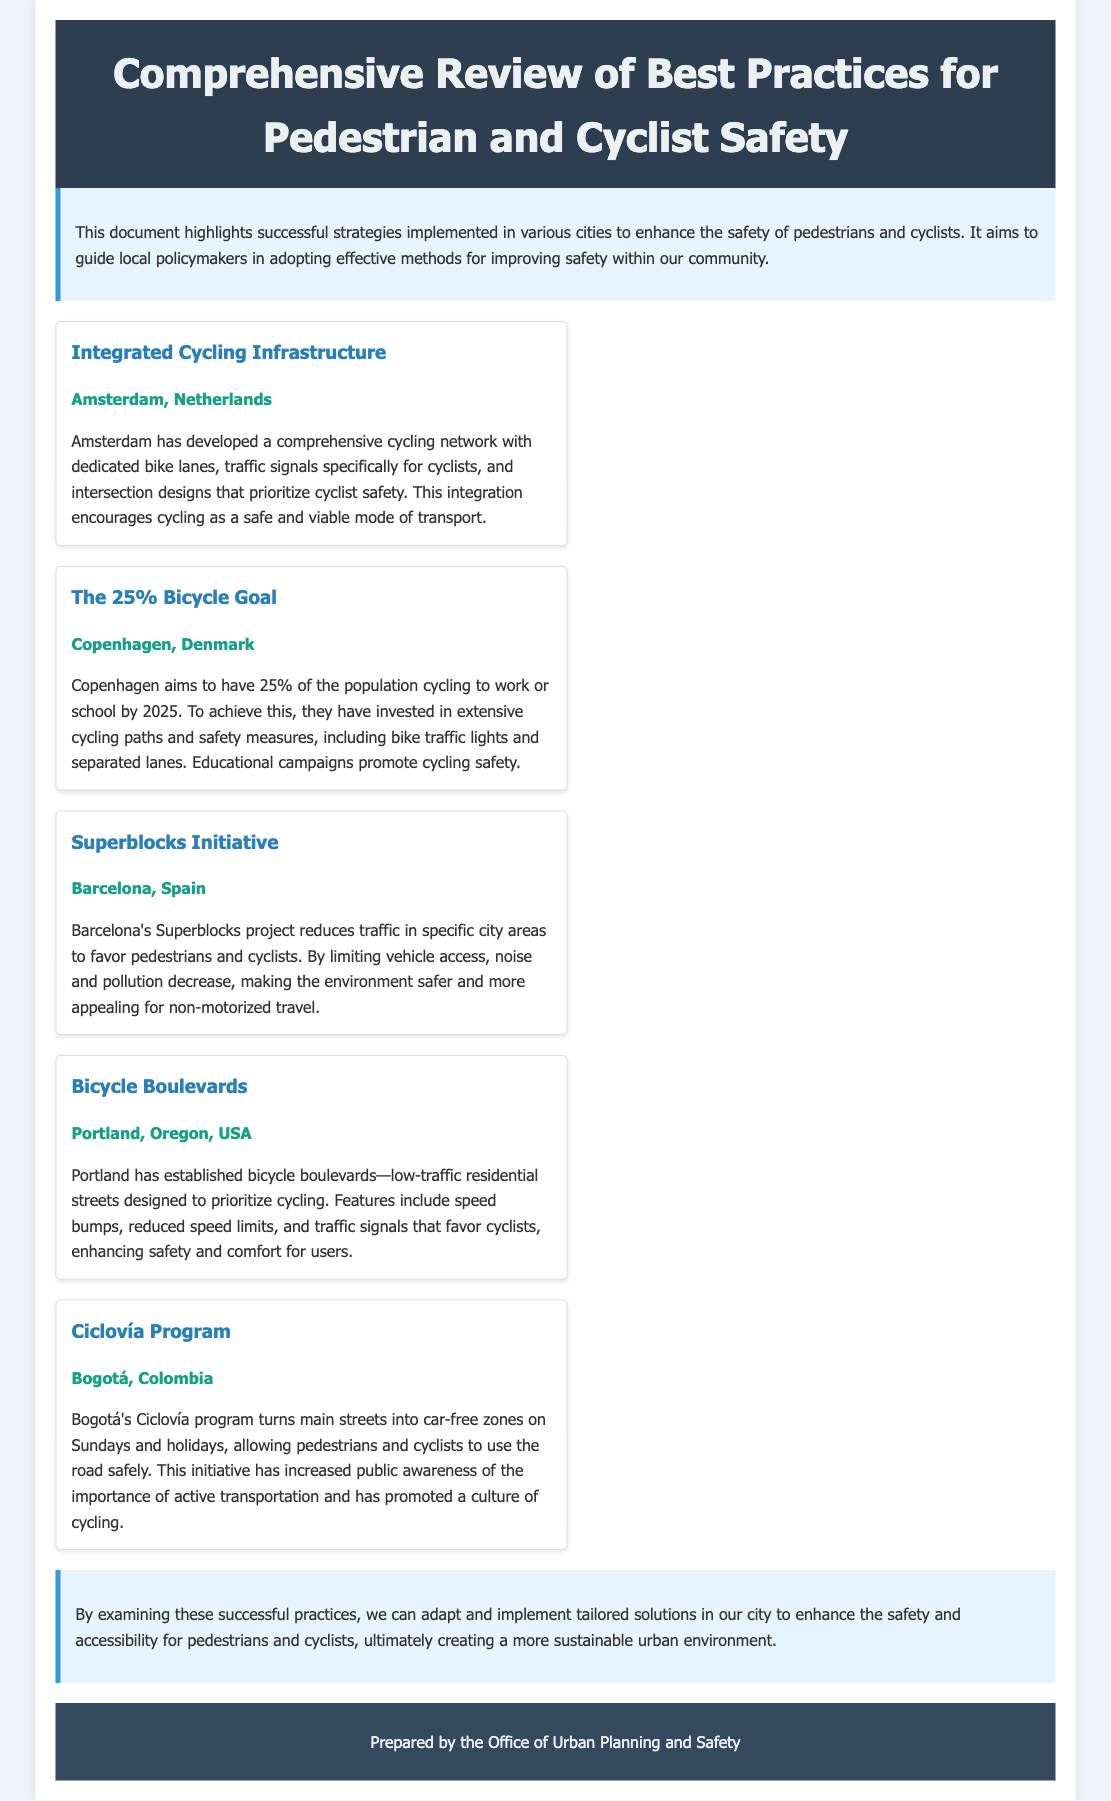What city is known for its Integrated Cycling Infrastructure? The document states that Amsterdam has developed a comprehensive cycling network with dedicated bike lanes, traffic signals specifically for cyclists, and intersection designs that prioritize cyclist safety.
Answer: Amsterdam What percentage of the population in Copenhagen aims to cycle by 2025? The text indicates that Copenhagen aims to have 25% of the population cycling to work or school by 2025.
Answer: 25% What initiative is aimed at reducing traffic and favoring pedestrians and cyclists in Barcelona? According to the document, Barcelona's Superblocks project reduces traffic in specific city areas to favor pedestrians and cyclists.
Answer: Superblocks Initiative What type of streets are Bicycle Boulevards designed for? The document describes that Portland has established bicycle boulevards—low-traffic residential streets designed to prioritize cycling.
Answer: Residential streets What does Bogotá's Ciclovía program do on Sundays and holidays? The text specifies that Bogotá's Ciclovía program turns main streets into car-free zones on Sundays and holidays, allowing pedestrians and cyclists to use the road safely.
Answer: Turns main streets into car-free zones Why is the conclusion section important in the document? The conclusion highlights that by examining successful practices, tailored solutions can be implemented in the city to enhance safety and accessibility.
Answer: Tailored solutions for safety and accessibility 